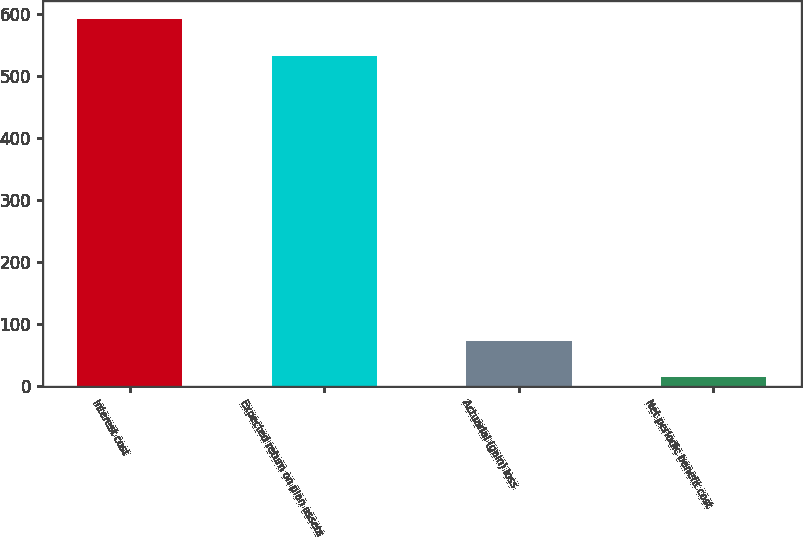Convert chart. <chart><loc_0><loc_0><loc_500><loc_500><bar_chart><fcel>Interest cost<fcel>Expected return on plan assets<fcel>Actuarial (gain) loss<fcel>Net periodic benefit cost<nl><fcel>592<fcel>533<fcel>72<fcel>14<nl></chart> 